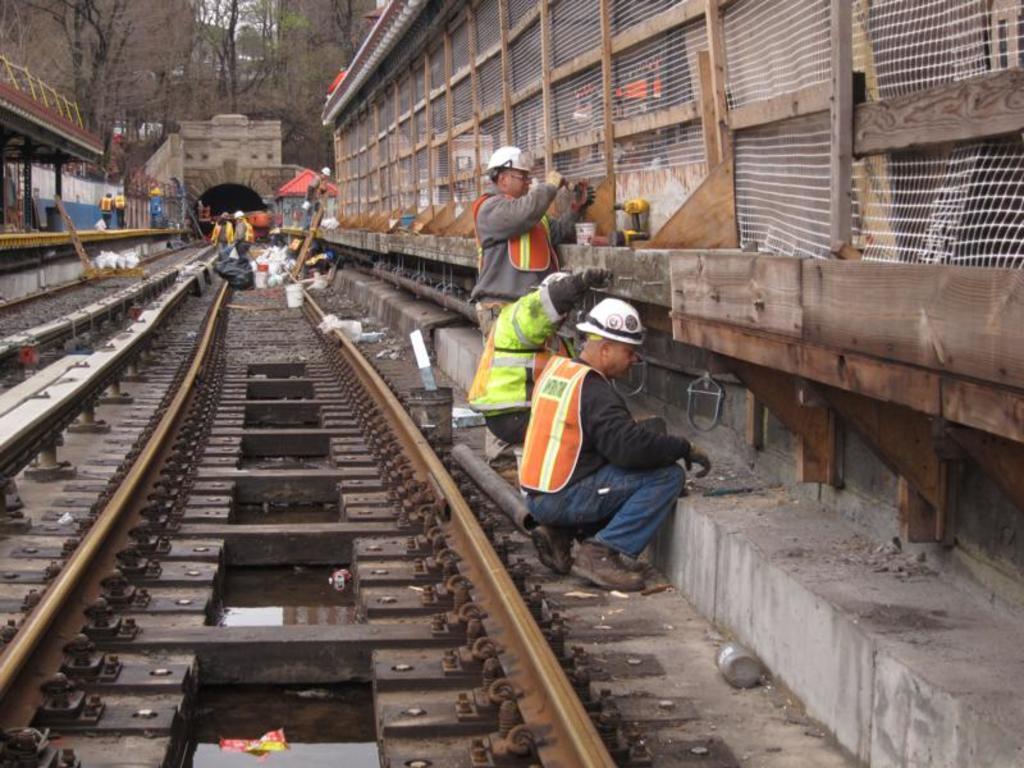In one or two sentences, can you explain what this image depicts? In this picture there are three men were working near to the railway track. In the background we can see another persons were standing near to the covers and buckets. At the top we can see many trees and a bridge. On the left we can see two persons were walking on the platform, behind them we can see fencing and shed. 